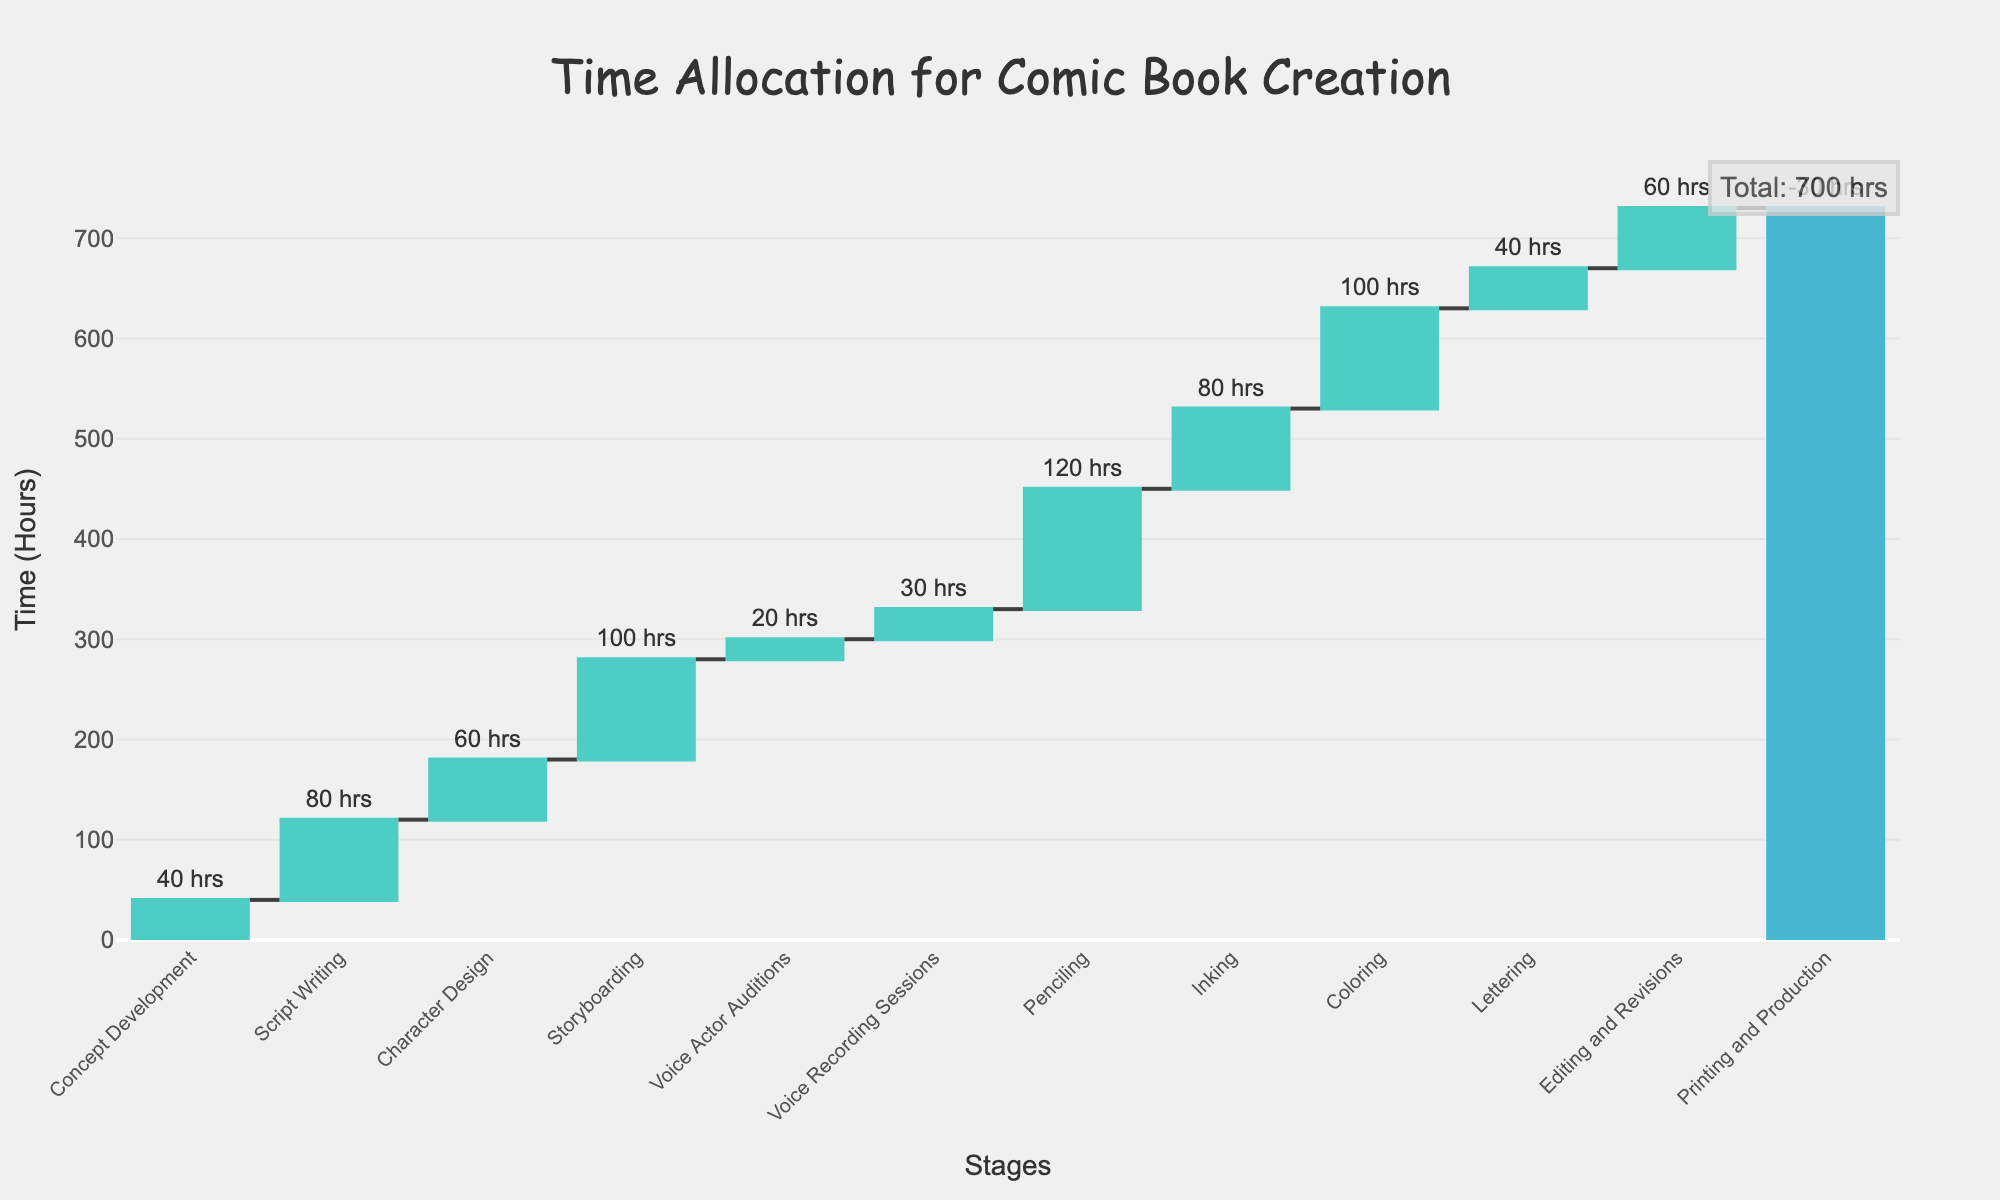What's the title of the chart? The title is displayed prominently at the top of the chart. Reading it directly will give the answer.
Answer: Time Allocation for Comic Book Creation What stage requires the most time? By examining the height of the bars, we can see the Penciling stage has the highest bar, indicating it requires the most time.
Answer: Penciling What is the cumulative time after the Storyboarding stage? To solve this, we add up the hours for all stages up to and including Storyboarding: 40 + 80 + 60 + 100 = 280 hours.
Answer: 280 hours Which stage added the least amount of time before the final total? By observing the smallest bar height before the total, Voice Actor Auditions has the smallest positive addition of 20 hours.
Answer: Voice Actor Auditions How many stages involved time reduction in the process? We identify stages with negative values. There’s only one stage, Printing and Production, with a bar extending below zero.
Answer: 1 stage (Printing and Production) What’s the total time allocated for stages involving voice actors? Add the hours for Voice Actor Auditions and Voice Recording Sessions: 20 + 30 = 50 hours.
Answer: 50 hours Which stage follows Character Design and requires a considerable amount of time? Look at the stage following Character Design which is Storyboarding with a significant duration of 100 hours.
Answer: Storyboarding How much time is allocated to editing and revisions combined with printing and production? Adding the editing and revisions time to the printing and production time: 60 + (-30) = 30 hours.
Answer: 30 hours What’s the difference in time allocation between Script Writing and Inking? Subtract the time for Inking from the time for Script Writing: 80 - 80 = 0 hours.
Answer: 0 hours Which stages contribute more than 80 hours to the total time allocation? Identify the stages with bar heights greater than 80 hours: Script Writing, Storyboarding, Penciling, and Coloring.
Answer: Script Writing, Storyboarding, Penciling, Coloring 